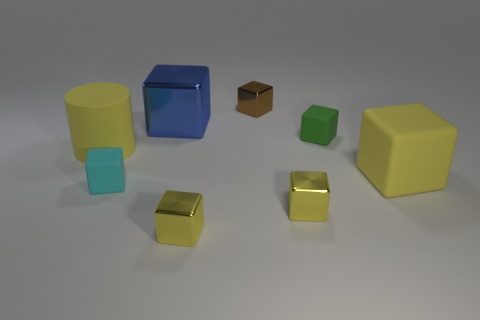Is the big cylinder the same color as the large rubber cube? While both the big cylinder and the large cube have a bluish hue, upon closer inspection, the cylinder exhibits a lighter, perhaps more sky blue, whereas the cube features a deeper, more royal blue. The ambient lighting may affect perception, but there is a distinguishable difference in their color tones. 